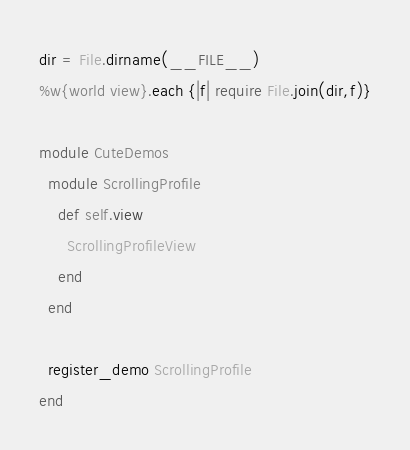<code> <loc_0><loc_0><loc_500><loc_500><_Ruby_>dir = File.dirname(__FILE__)
%w{world view}.each {|f| require File.join(dir,f)}

module CuteDemos
  module ScrollingProfile
    def self.view
      ScrollingProfileView
    end
  end
  
  register_demo ScrollingProfile
end</code> 